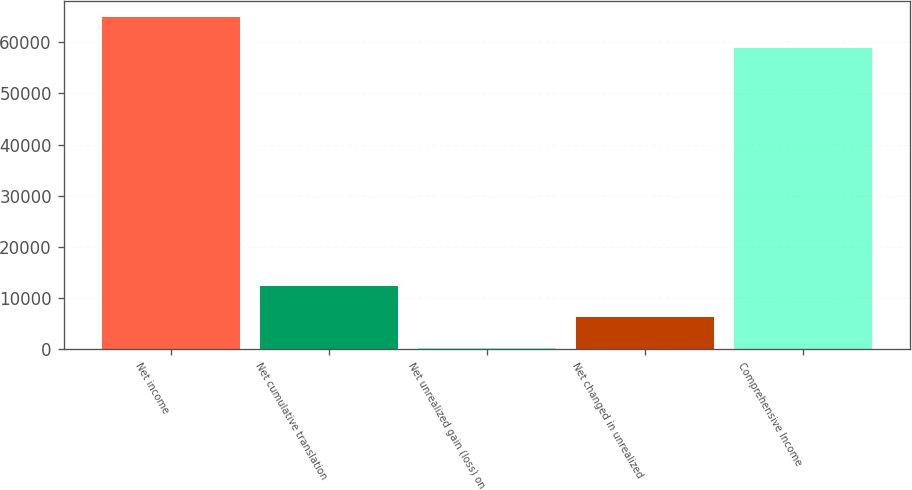Convert chart. <chart><loc_0><loc_0><loc_500><loc_500><bar_chart><fcel>Net income<fcel>Net cumulative translation<fcel>Net unrealized gain (loss) on<fcel>Net changed in unrealized<fcel>Comprehensive Income<nl><fcel>64830.7<fcel>12287.4<fcel>342<fcel>6314.7<fcel>58858<nl></chart> 